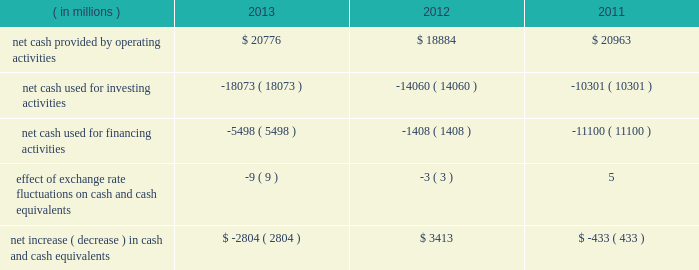In summary , our cash flows for each period were as follows: .
Operating activities cash provided by operating activities is net income adjusted for certain non-cash items and changes in certain assets and liabilities .
For 2013 compared to 2012 , the $ 1.9 billion increase in cash provided by operating activities was due to changes in working capital , partially offset by lower net income in 2013 .
Income taxes paid , net of refunds , in 2013 compared to 2012 were $ 1.1 billion lower due to lower income before taxes in 2013 and 2012 income tax overpayments .
Changes in assets and liabilities as of december 28 , 2013 , compared to december 29 , 2012 , included lower income taxes payable and receivable resulting from a reduction in taxes due in 2013 , and lower inventories due to the sell-through of older-generation products , partially offset by the ramp of 4th generation intel core processor family products .
For 2013 , our three largest customers accounted for 44% ( 44 % ) of our net revenue ( 43% ( 43 % ) in 2012 and 2011 ) , with hewlett- packard company accounting for 17% ( 17 % ) of our net revenue ( 18% ( 18 % ) in 2012 and 19% ( 19 % ) in 2011 ) , dell accounting for 15% ( 15 % ) of our net revenue ( 14% ( 14 % ) in 2012 and 15% ( 15 % ) in 2011 ) , and lenovo accounting for 12% ( 12 % ) of our net revenue ( 11% ( 11 % ) in 2012 and 9% ( 9 % ) in 2011 ) .
These three customers accounted for 34% ( 34 % ) of our accounts receivable as of december 28 , 2013 ( 33% ( 33 % ) as of december 29 , 2012 ) .
For 2012 compared to 2011 , the $ 2.1 billion decrease in cash provided by operating activities was due to lower net income and changes in our working capital , partially offset by adjustments for non-cash items .
The adjustments for noncash items were higher due primarily to higher depreciation in 2012 compared to 2011 , partially offset by increases in non-acquisition-related deferred tax liabilities as of december 31 , 2011 .
Investing activities investing cash flows consist primarily of capital expenditures ; investment purchases , sales , maturities , and disposals ; as well as cash used for acquisitions .
The increase in cash used for investing activities in 2013 compared to 2012 was primarily due to an increase in purchases of available-for-sale investments and a decrease in maturities and sales of trading assets , partially offset by an increase in maturities and sales of available-for-sale investments and a decrease in purchases of licensed technology and patents .
Our capital expenditures were $ 10.7 billion in 2013 ( $ 11.0 billion in 2012 and $ 10.8 billion in 2011 ) .
Cash used for investing activities increased in 2012 compared to 2011 primarily due to net purchases of available- for-sale investments and trading assets in 2012 , as compared to net maturities and sales of available-for-sale investments and trading assets in 2011 , partially offset by a decrease in cash paid for acquisitions .
Net purchases of available-for-sale investments in 2012 included our purchase of $ 3.2 billion of equity securities in asml in q3 2012 .
Financing activities financing cash flows consist primarily of repurchases of common stock , payment of dividends to stockholders , issuance and repayment of long-term debt , and proceeds from the sale of shares through employee equity incentive plans .
Table of contents management 2019s discussion and analysis of financial condition and results of operations ( continued ) .
What was the percentage change in net cash provided by operating activities between 2011 and 2012? 
Computations: ((18884 - 20963) / 20963)
Answer: -0.09917. 